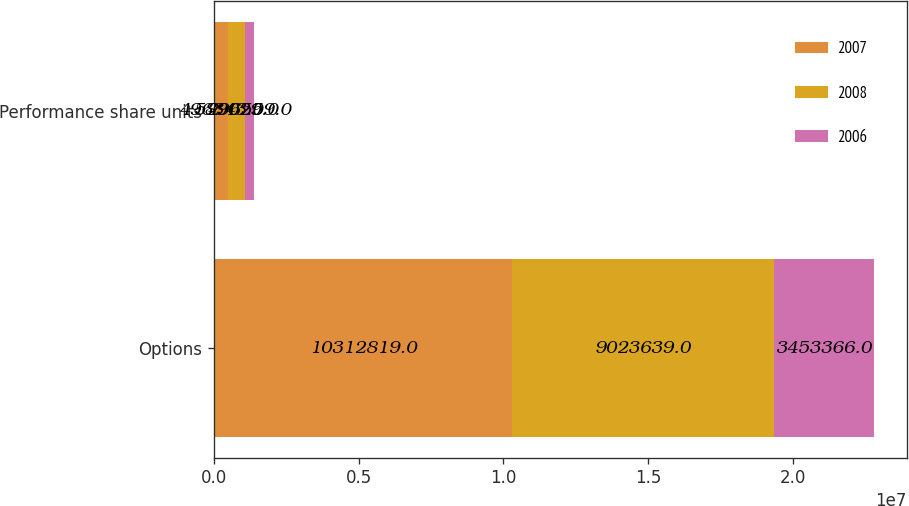Convert chart to OTSL. <chart><loc_0><loc_0><loc_500><loc_500><stacked_bar_chart><ecel><fcel>Options<fcel>Performance share units<nl><fcel>2007<fcel>1.03128e+07<fcel>496343<nl><fcel>2008<fcel>9.02364e+06<fcel>589029<nl><fcel>2006<fcel>3.45337e+06<fcel>296559<nl></chart> 